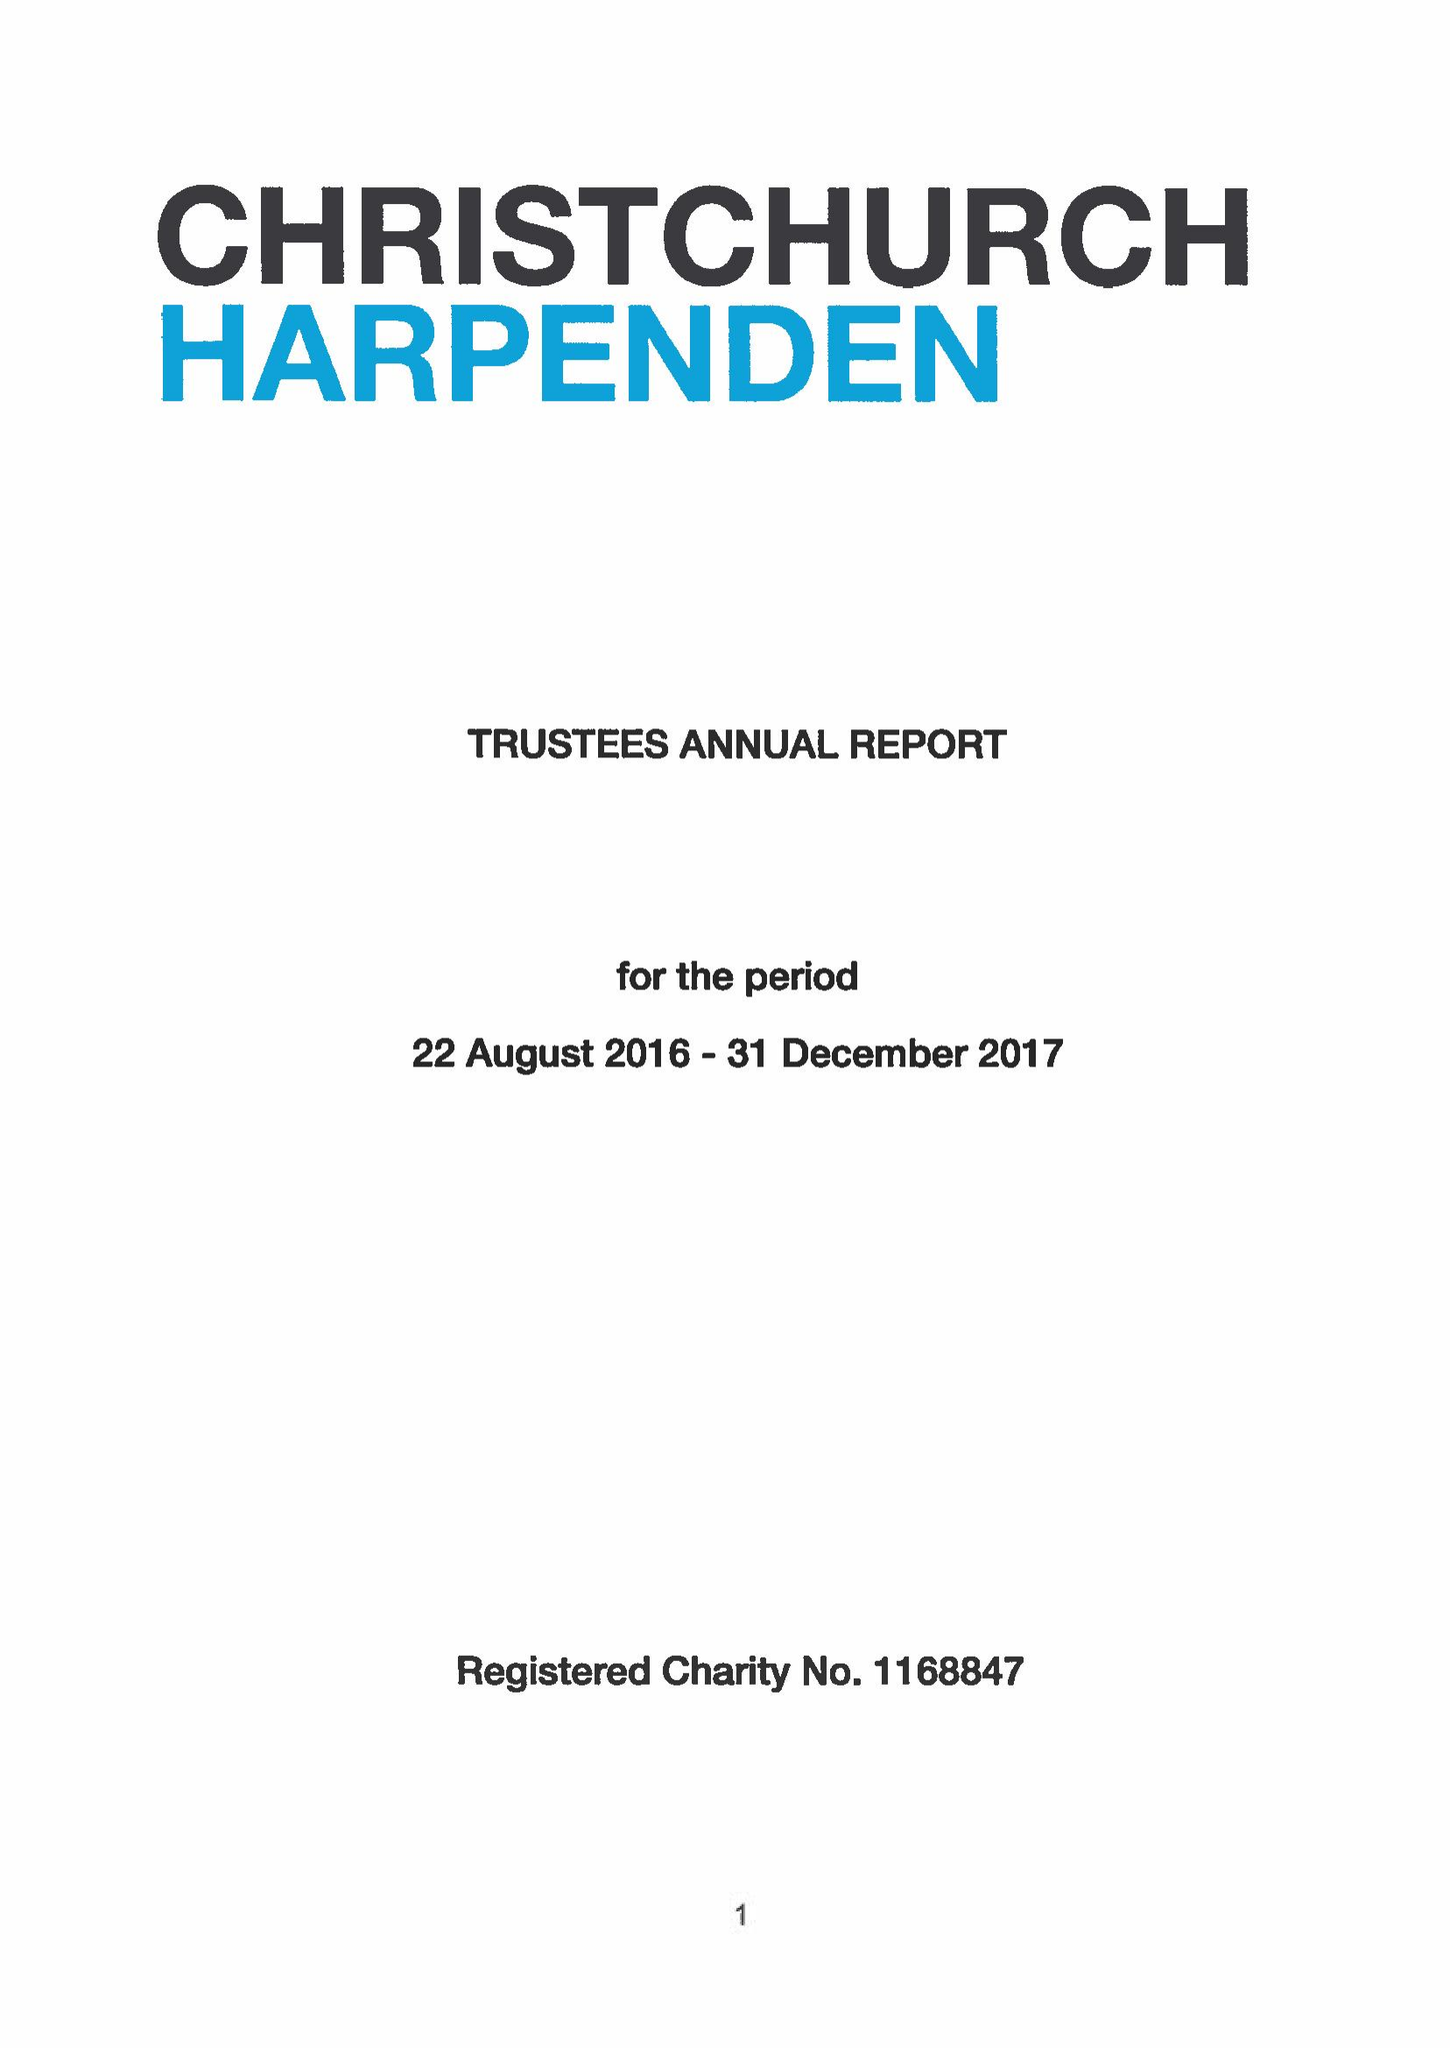What is the value for the spending_annually_in_british_pounds?
Answer the question using a single word or phrase. 411382.00 